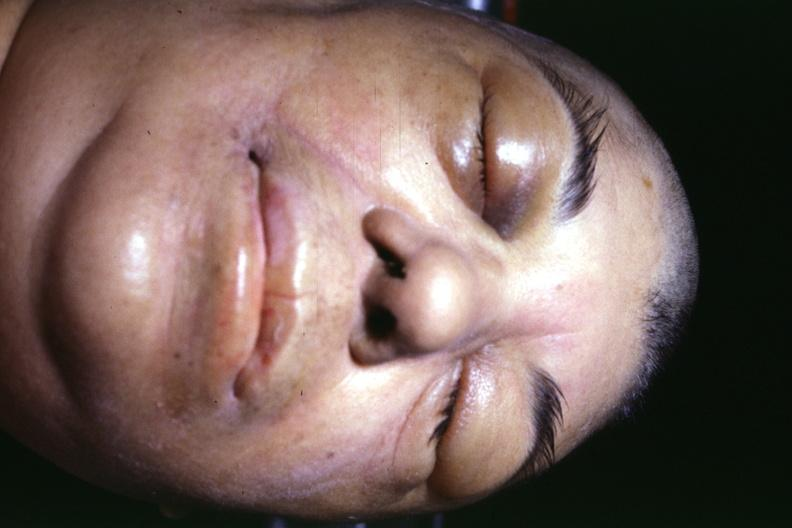why does this image show jaundice?
Answer the question using a single word or phrase. Due to terminal alcoholic cirrhosis with shock and typical facial appearance of edema due to generalized capillary permeability increase or shock 